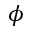<formula> <loc_0><loc_0><loc_500><loc_500>\phi</formula> 